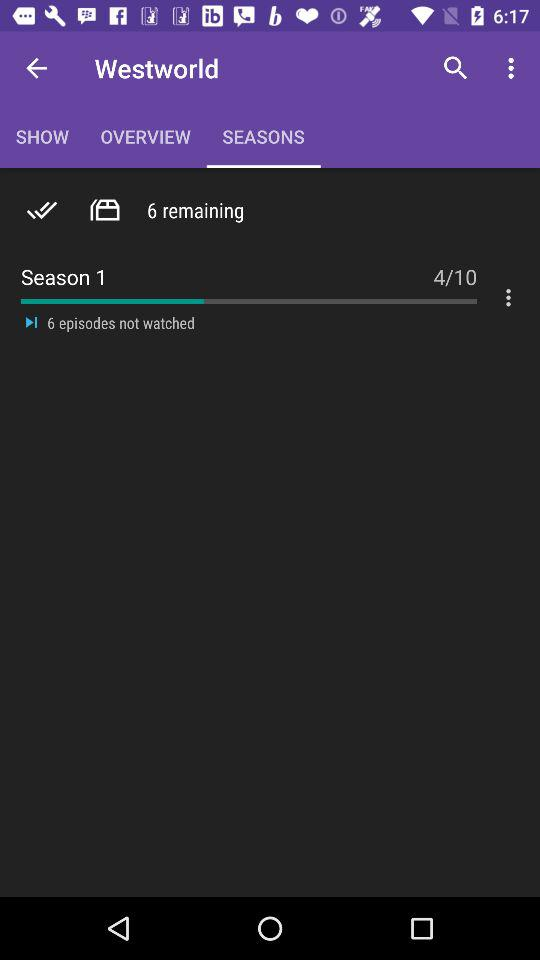How many episodes are there in total? There are 10 episodes in total. 